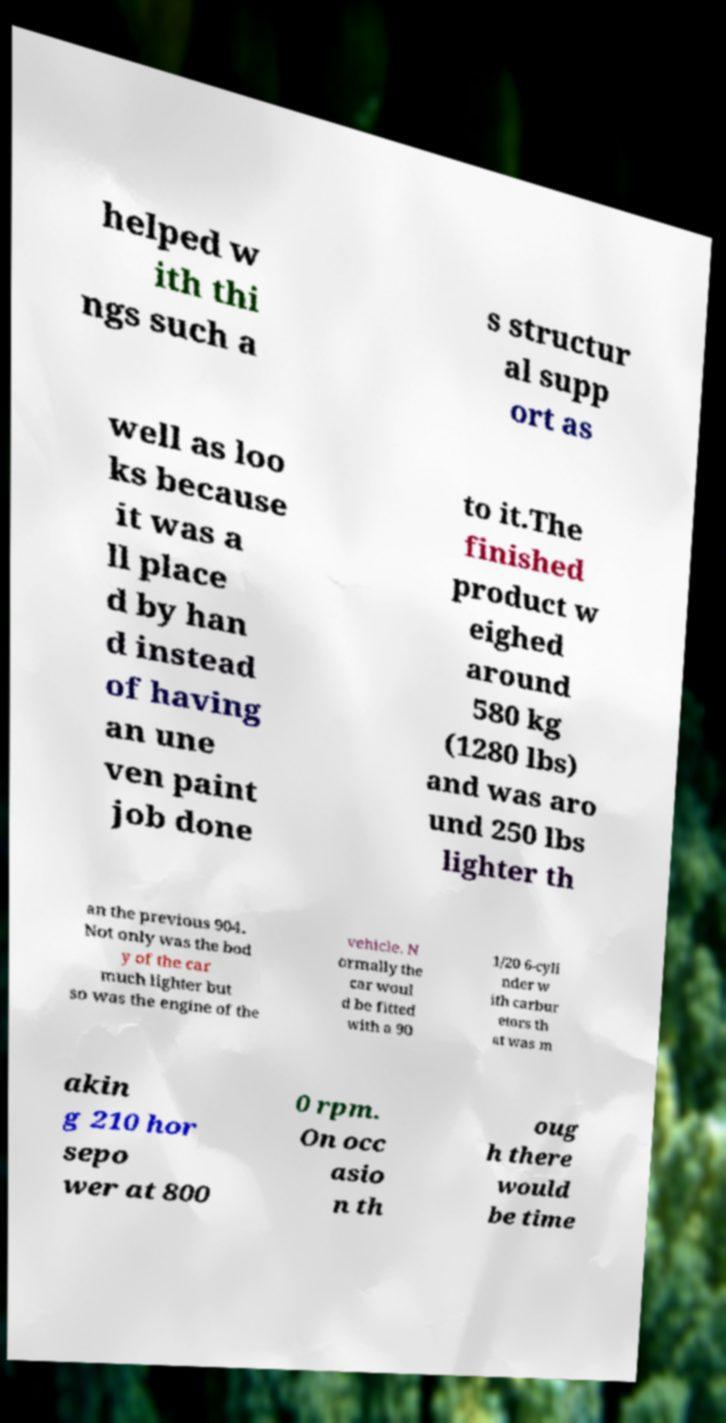Please read and relay the text visible in this image. What does it say? helped w ith thi ngs such a s structur al supp ort as well as loo ks because it was a ll place d by han d instead of having an une ven paint job done to it.The finished product w eighed around 580 kg (1280 lbs) and was aro und 250 lbs lighter th an the previous 904. Not only was the bod y of the car much lighter but so was the engine of the vehicle. N ormally the car woul d be fitted with a 90 1/20 6-cyli nder w ith carbur etors th at was m akin g 210 hor sepo wer at 800 0 rpm. On occ asio n th oug h there would be time 